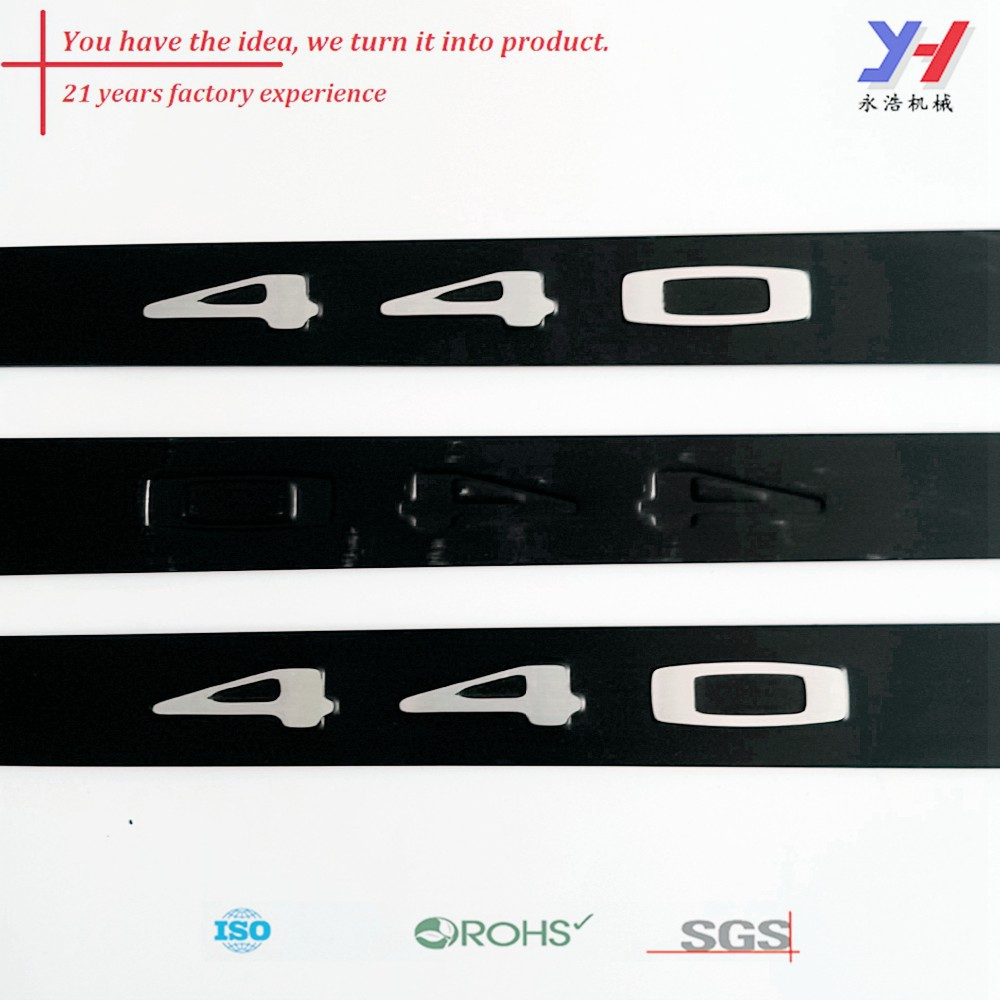What does the certification at the bottom of the image indicate? The certifications displayed at the bottom of the image, namely ISO, RoHS, and SGS, indicate that the company's products adhere to various international standards. ISO certification signifies that the company meets the International Organization for Standardization's quality management standards. RoHS (Restriction of Hazardous Substances) compliance indicates that the products are free from specific hazardous materials. SGS certification is a mark of quality and integrity, verifying that the products meet regulatory standards through comprehensive testing and inspection. 